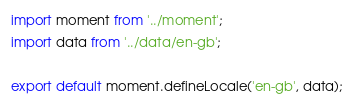<code> <loc_0><loc_0><loc_500><loc_500><_JavaScript_>import moment from '../moment';
import data from '../data/en-gb';

export default moment.defineLocale('en-gb', data);

</code> 